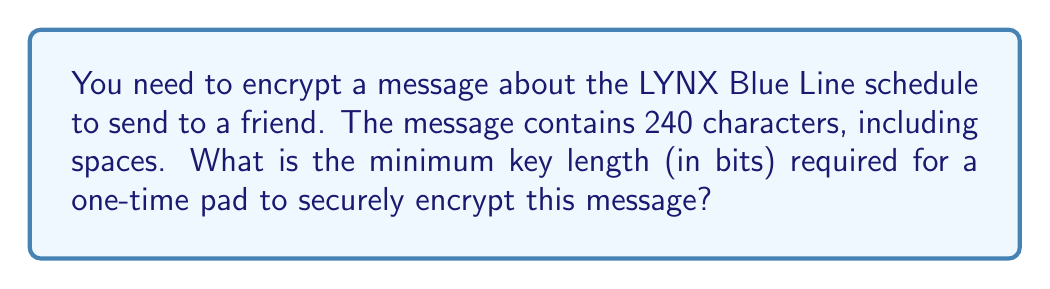Provide a solution to this math problem. To determine the minimum key length for a one-time pad, we need to follow these steps:

1. Understand the principle of one-time pad:
   A one-time pad requires a key that is:
   a) As long as the message
   b) Truly random
   c) Used only once

2. Calculate the number of bits needed to represent each character:
   In most common encoding schemes (e.g., ASCII), each character is represented by 8 bits.

3. Calculate the total number of bits in the message:
   $$\text{Total bits} = \text{Number of characters} \times \text{Bits per character}$$
   $$\text{Total bits} = 240 \times 8 = 1920 \text{ bits}$$

4. Determine the minimum key length:
   The key must be at least as long as the message in bits.
   Therefore, the minimum key length is also 1920 bits.
Answer: 1920 bits 